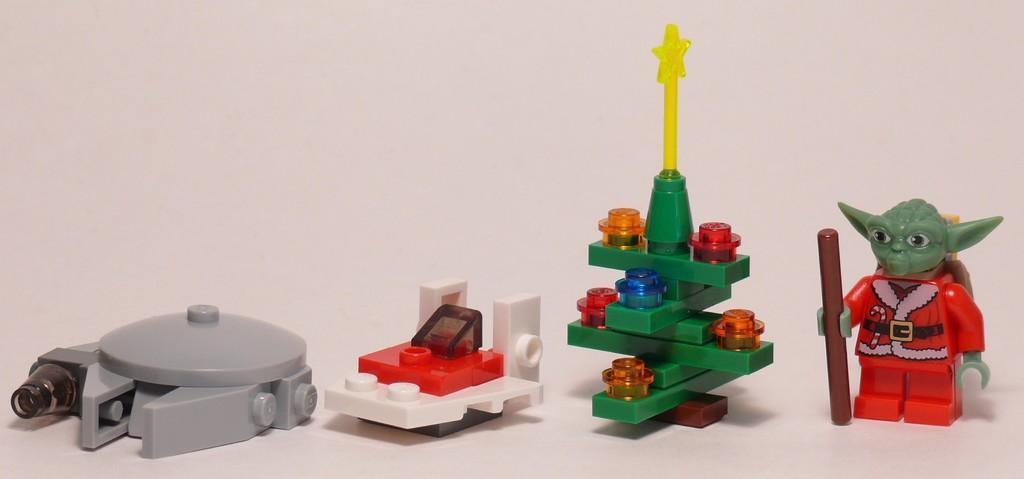Could you give a brief overview of what you see in this image? In this image I see the lego toys which are colorful and these all toys are on the white surface and it is white in the background. 